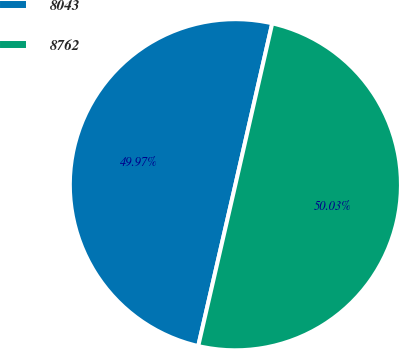<chart> <loc_0><loc_0><loc_500><loc_500><pie_chart><fcel>8043<fcel>8762<nl><fcel>49.97%<fcel>50.03%<nl></chart> 